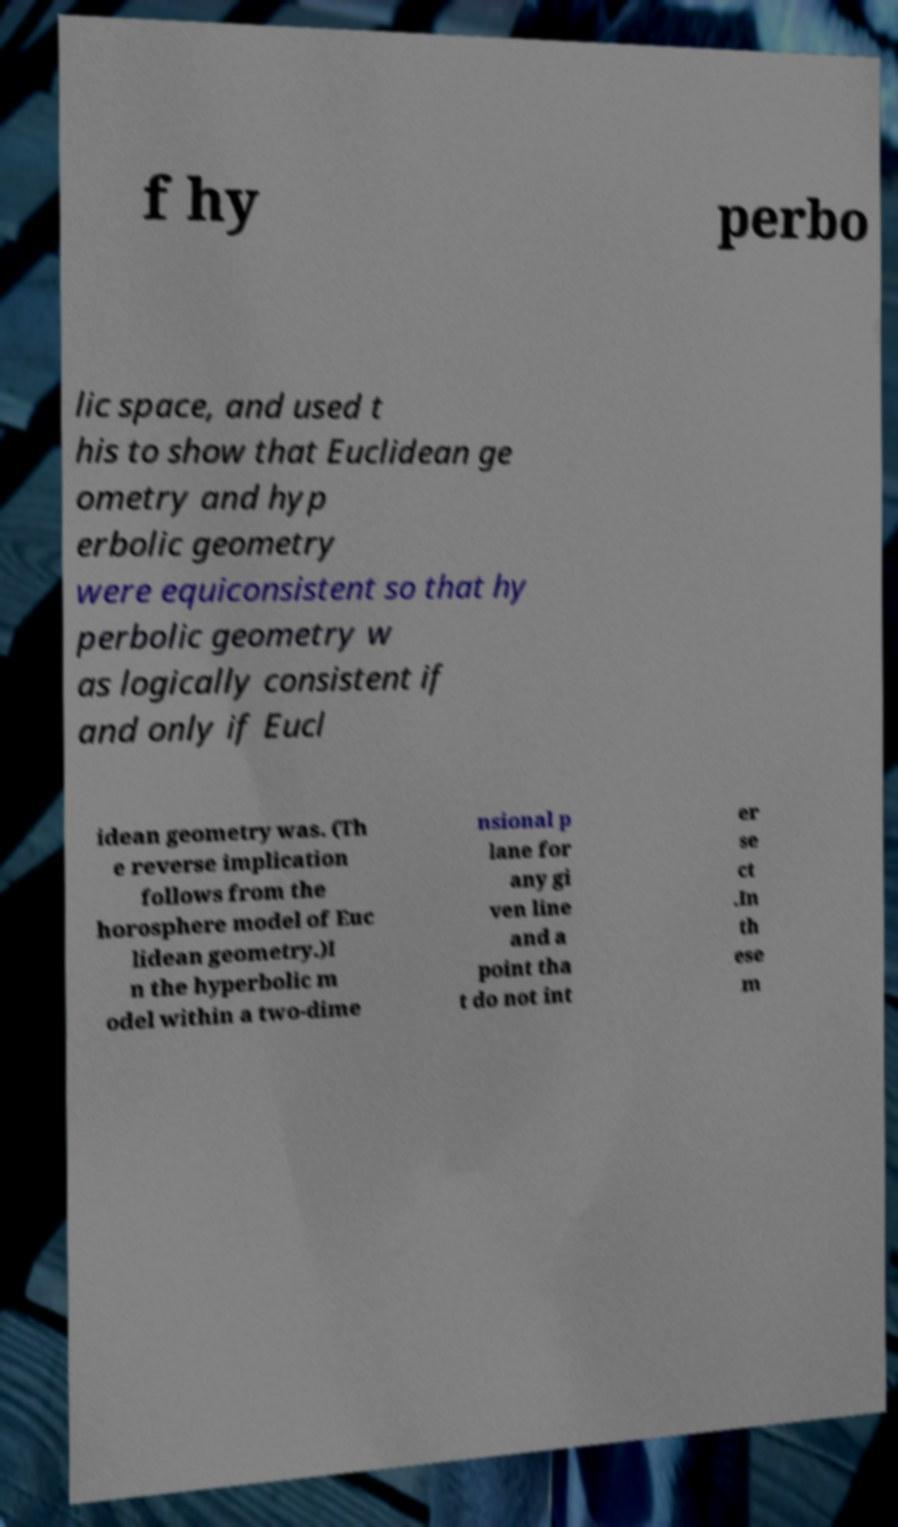I need the written content from this picture converted into text. Can you do that? f hy perbo lic space, and used t his to show that Euclidean ge ometry and hyp erbolic geometry were equiconsistent so that hy perbolic geometry w as logically consistent if and only if Eucl idean geometry was. (Th e reverse implication follows from the horosphere model of Euc lidean geometry.)I n the hyperbolic m odel within a two-dime nsional p lane for any gi ven line and a point tha t do not int er se ct .In th ese m 